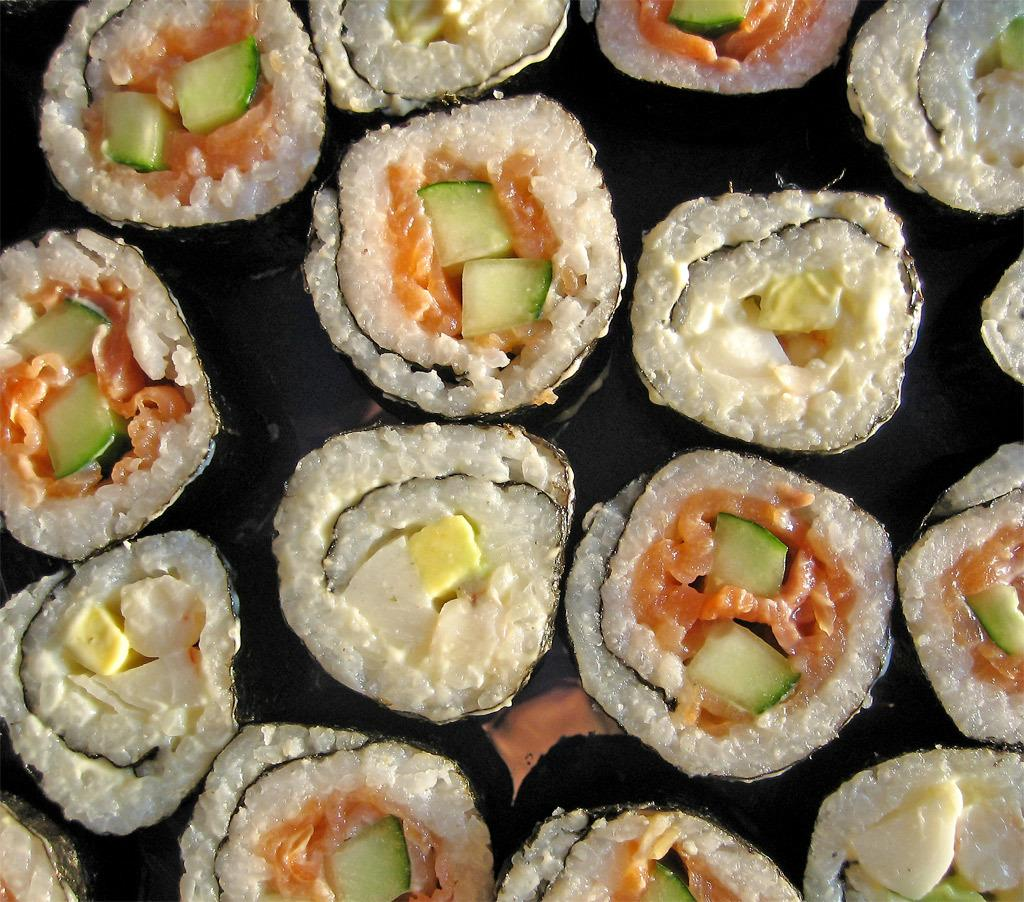What type of food is visible in the image? There is sushi in the in the image. Where is the sushi located in the image? The sushi is placed on a surface. What type of star is protesting against the minister in the image? There is no star, protest, or minister present in the image. 